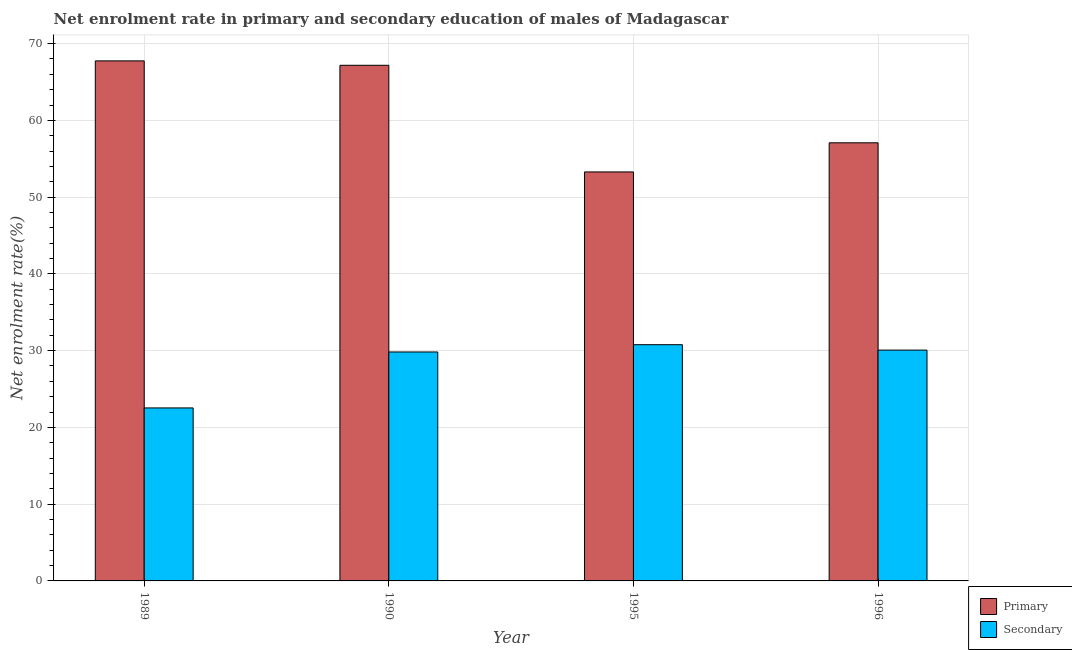How many groups of bars are there?
Make the answer very short. 4. What is the enrollment rate in secondary education in 1990?
Give a very brief answer. 29.83. Across all years, what is the maximum enrollment rate in primary education?
Your answer should be very brief. 67.75. Across all years, what is the minimum enrollment rate in secondary education?
Provide a succinct answer. 22.54. In which year was the enrollment rate in primary education maximum?
Provide a succinct answer. 1989. In which year was the enrollment rate in secondary education minimum?
Provide a short and direct response. 1989. What is the total enrollment rate in secondary education in the graph?
Provide a short and direct response. 113.21. What is the difference between the enrollment rate in primary education in 1990 and that in 1996?
Give a very brief answer. 10.1. What is the difference between the enrollment rate in primary education in 1990 and the enrollment rate in secondary education in 1989?
Ensure brevity in your answer.  -0.58. What is the average enrollment rate in secondary education per year?
Provide a succinct answer. 28.3. In the year 1989, what is the difference between the enrollment rate in secondary education and enrollment rate in primary education?
Ensure brevity in your answer.  0. In how many years, is the enrollment rate in secondary education greater than 68 %?
Offer a very short reply. 0. What is the ratio of the enrollment rate in primary education in 1990 to that in 1995?
Give a very brief answer. 1.26. Is the difference between the enrollment rate in secondary education in 1995 and 1996 greater than the difference between the enrollment rate in primary education in 1995 and 1996?
Ensure brevity in your answer.  No. What is the difference between the highest and the second highest enrollment rate in primary education?
Provide a short and direct response. 0.58. What is the difference between the highest and the lowest enrollment rate in primary education?
Provide a short and direct response. 14.47. In how many years, is the enrollment rate in secondary education greater than the average enrollment rate in secondary education taken over all years?
Offer a very short reply. 3. Is the sum of the enrollment rate in secondary education in 1990 and 1996 greater than the maximum enrollment rate in primary education across all years?
Keep it short and to the point. Yes. What does the 2nd bar from the left in 1989 represents?
Keep it short and to the point. Secondary. What does the 1st bar from the right in 1990 represents?
Give a very brief answer. Secondary. What is the difference between two consecutive major ticks on the Y-axis?
Give a very brief answer. 10. Does the graph contain grids?
Ensure brevity in your answer.  Yes. How many legend labels are there?
Provide a succinct answer. 2. How are the legend labels stacked?
Make the answer very short. Vertical. What is the title of the graph?
Give a very brief answer. Net enrolment rate in primary and secondary education of males of Madagascar. Does "Non-residents" appear as one of the legend labels in the graph?
Ensure brevity in your answer.  No. What is the label or title of the Y-axis?
Your answer should be compact. Net enrolment rate(%). What is the Net enrolment rate(%) of Primary in 1989?
Offer a terse response. 67.75. What is the Net enrolment rate(%) in Secondary in 1989?
Your answer should be compact. 22.54. What is the Net enrolment rate(%) in Primary in 1990?
Offer a very short reply. 67.18. What is the Net enrolment rate(%) in Secondary in 1990?
Keep it short and to the point. 29.83. What is the Net enrolment rate(%) of Primary in 1995?
Ensure brevity in your answer.  53.28. What is the Net enrolment rate(%) in Secondary in 1995?
Your response must be concise. 30.78. What is the Net enrolment rate(%) in Primary in 1996?
Give a very brief answer. 57.08. What is the Net enrolment rate(%) in Secondary in 1996?
Provide a succinct answer. 30.07. Across all years, what is the maximum Net enrolment rate(%) of Primary?
Offer a terse response. 67.75. Across all years, what is the maximum Net enrolment rate(%) of Secondary?
Provide a succinct answer. 30.78. Across all years, what is the minimum Net enrolment rate(%) of Primary?
Your answer should be compact. 53.28. Across all years, what is the minimum Net enrolment rate(%) of Secondary?
Your answer should be very brief. 22.54. What is the total Net enrolment rate(%) of Primary in the graph?
Your answer should be compact. 245.29. What is the total Net enrolment rate(%) in Secondary in the graph?
Give a very brief answer. 113.21. What is the difference between the Net enrolment rate(%) in Primary in 1989 and that in 1990?
Keep it short and to the point. 0.58. What is the difference between the Net enrolment rate(%) in Secondary in 1989 and that in 1990?
Offer a very short reply. -7.29. What is the difference between the Net enrolment rate(%) in Primary in 1989 and that in 1995?
Make the answer very short. 14.47. What is the difference between the Net enrolment rate(%) in Secondary in 1989 and that in 1995?
Offer a terse response. -8.24. What is the difference between the Net enrolment rate(%) of Primary in 1989 and that in 1996?
Make the answer very short. 10.67. What is the difference between the Net enrolment rate(%) in Secondary in 1989 and that in 1996?
Make the answer very short. -7.53. What is the difference between the Net enrolment rate(%) of Primary in 1990 and that in 1995?
Your answer should be compact. 13.89. What is the difference between the Net enrolment rate(%) in Secondary in 1990 and that in 1995?
Your response must be concise. -0.95. What is the difference between the Net enrolment rate(%) in Primary in 1990 and that in 1996?
Make the answer very short. 10.1. What is the difference between the Net enrolment rate(%) in Secondary in 1990 and that in 1996?
Offer a very short reply. -0.25. What is the difference between the Net enrolment rate(%) of Primary in 1995 and that in 1996?
Offer a terse response. -3.8. What is the difference between the Net enrolment rate(%) of Secondary in 1995 and that in 1996?
Offer a terse response. 0.7. What is the difference between the Net enrolment rate(%) of Primary in 1989 and the Net enrolment rate(%) of Secondary in 1990?
Keep it short and to the point. 37.93. What is the difference between the Net enrolment rate(%) of Primary in 1989 and the Net enrolment rate(%) of Secondary in 1995?
Provide a succinct answer. 36.98. What is the difference between the Net enrolment rate(%) of Primary in 1989 and the Net enrolment rate(%) of Secondary in 1996?
Your answer should be very brief. 37.68. What is the difference between the Net enrolment rate(%) of Primary in 1990 and the Net enrolment rate(%) of Secondary in 1995?
Your answer should be very brief. 36.4. What is the difference between the Net enrolment rate(%) in Primary in 1990 and the Net enrolment rate(%) in Secondary in 1996?
Your response must be concise. 37.1. What is the difference between the Net enrolment rate(%) of Primary in 1995 and the Net enrolment rate(%) of Secondary in 1996?
Your answer should be very brief. 23.21. What is the average Net enrolment rate(%) of Primary per year?
Keep it short and to the point. 61.32. What is the average Net enrolment rate(%) in Secondary per year?
Ensure brevity in your answer.  28.3. In the year 1989, what is the difference between the Net enrolment rate(%) of Primary and Net enrolment rate(%) of Secondary?
Your response must be concise. 45.21. In the year 1990, what is the difference between the Net enrolment rate(%) of Primary and Net enrolment rate(%) of Secondary?
Ensure brevity in your answer.  37.35. In the year 1995, what is the difference between the Net enrolment rate(%) of Primary and Net enrolment rate(%) of Secondary?
Offer a terse response. 22.51. In the year 1996, what is the difference between the Net enrolment rate(%) in Primary and Net enrolment rate(%) in Secondary?
Give a very brief answer. 27.01. What is the ratio of the Net enrolment rate(%) of Primary in 1989 to that in 1990?
Provide a short and direct response. 1.01. What is the ratio of the Net enrolment rate(%) in Secondary in 1989 to that in 1990?
Offer a terse response. 0.76. What is the ratio of the Net enrolment rate(%) in Primary in 1989 to that in 1995?
Your response must be concise. 1.27. What is the ratio of the Net enrolment rate(%) in Secondary in 1989 to that in 1995?
Provide a succinct answer. 0.73. What is the ratio of the Net enrolment rate(%) in Primary in 1989 to that in 1996?
Your answer should be compact. 1.19. What is the ratio of the Net enrolment rate(%) in Secondary in 1989 to that in 1996?
Offer a terse response. 0.75. What is the ratio of the Net enrolment rate(%) in Primary in 1990 to that in 1995?
Keep it short and to the point. 1.26. What is the ratio of the Net enrolment rate(%) in Secondary in 1990 to that in 1995?
Your response must be concise. 0.97. What is the ratio of the Net enrolment rate(%) of Primary in 1990 to that in 1996?
Provide a short and direct response. 1.18. What is the ratio of the Net enrolment rate(%) of Primary in 1995 to that in 1996?
Your answer should be compact. 0.93. What is the ratio of the Net enrolment rate(%) in Secondary in 1995 to that in 1996?
Make the answer very short. 1.02. What is the difference between the highest and the second highest Net enrolment rate(%) of Primary?
Offer a very short reply. 0.58. What is the difference between the highest and the second highest Net enrolment rate(%) of Secondary?
Your response must be concise. 0.7. What is the difference between the highest and the lowest Net enrolment rate(%) in Primary?
Your answer should be compact. 14.47. What is the difference between the highest and the lowest Net enrolment rate(%) of Secondary?
Your answer should be very brief. 8.24. 